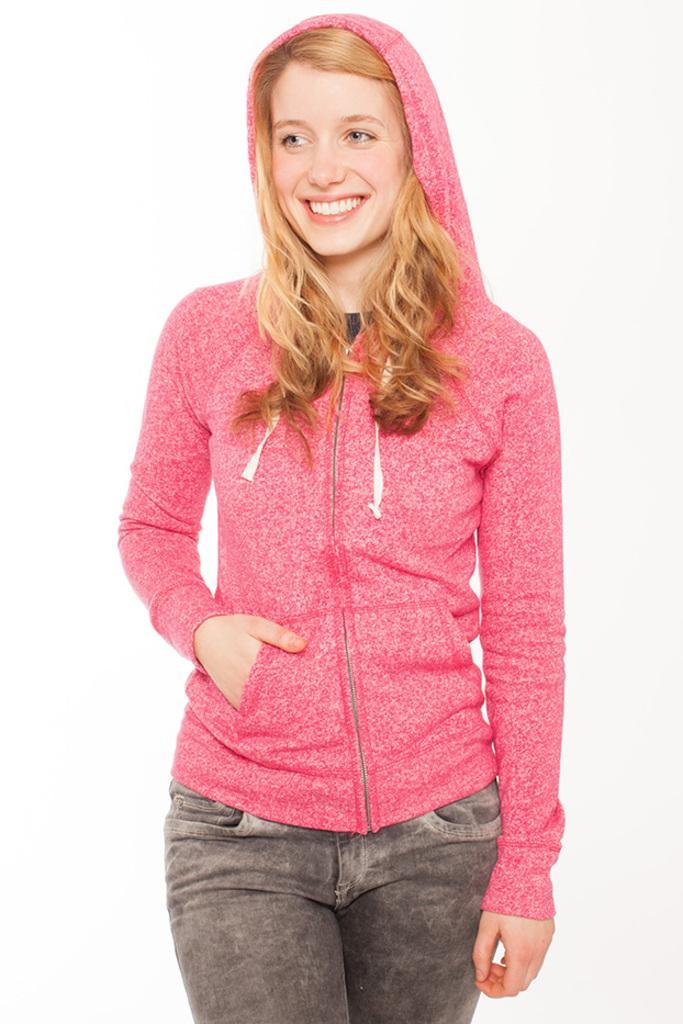Can you describe this image briefly? There is a lady wearing a jacket is standing and smiling. In the background it is white. 